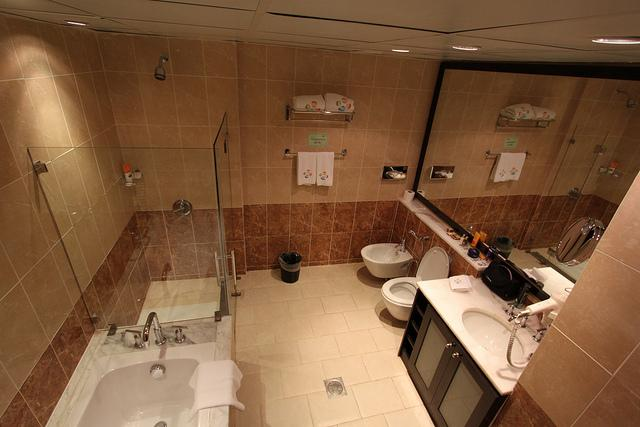What kind of bathroom is this? hotel 